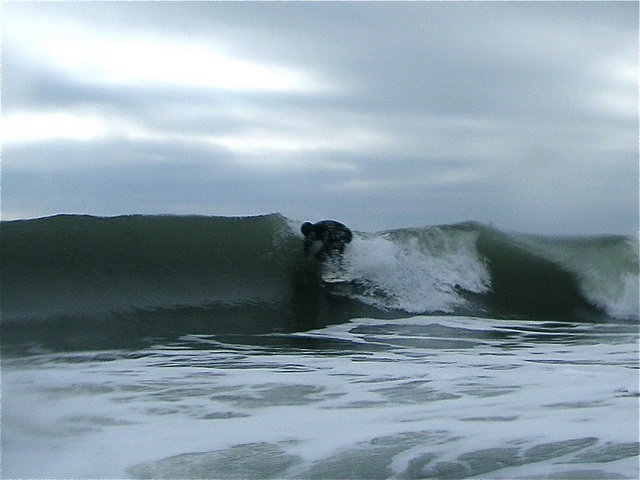Describe the objects in this image and their specific colors. I can see people in white, black, darkgray, navy, and gray tones and surfboard in white, gray, and darkgray tones in this image. 